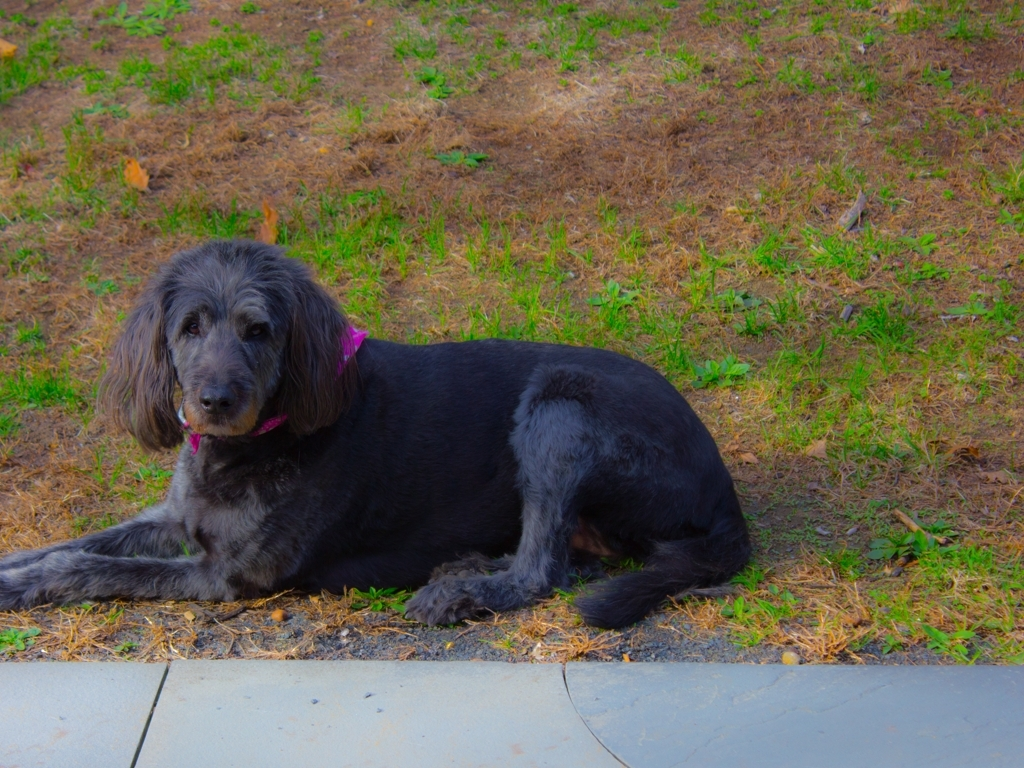Is the aesthetic appeal of the main subject in the photograph high? The aesthetic appeal of a subject in a photograph can be quite subjective, but this photo captures the dog with a gentle demeanor amidst a natural background, which may be considered aesthetically pleasing to some viewers. The photo's composition, color balance, and the subject's relaxed pose contribute to its overall charm. 